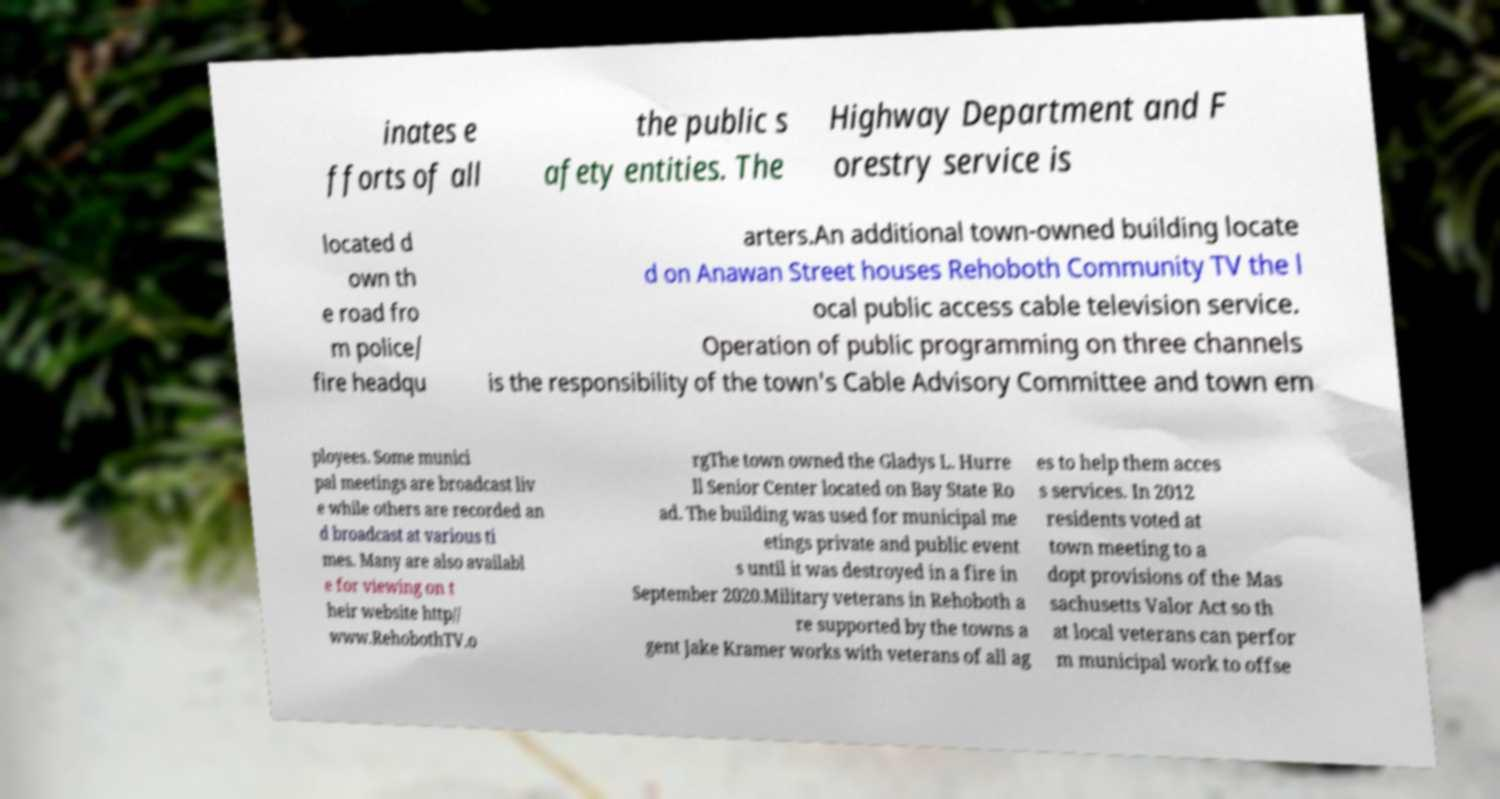There's text embedded in this image that I need extracted. Can you transcribe it verbatim? inates e fforts of all the public s afety entities. The Highway Department and F orestry service is located d own th e road fro m police/ fire headqu arters.An additional town-owned building locate d on Anawan Street houses Rehoboth Community TV the l ocal public access cable television service. Operation of public programming on three channels is the responsibility of the town's Cable Advisory Committee and town em ployees. Some munici pal meetings are broadcast liv e while others are recorded an d broadcast at various ti mes. Many are also availabl e for viewing on t heir website http// www.RehobothTV.o rgThe town owned the Gladys L. Hurre ll Senior Center located on Bay State Ro ad. The building was used for municipal me etings private and public event s until it was destroyed in a fire in September 2020.Military veterans in Rehoboth a re supported by the towns a gent Jake Kramer works with veterans of all ag es to help them acces s services. In 2012 residents voted at town meeting to a dopt provisions of the Mas sachusetts Valor Act so th at local veterans can perfor m municipal work to offse 